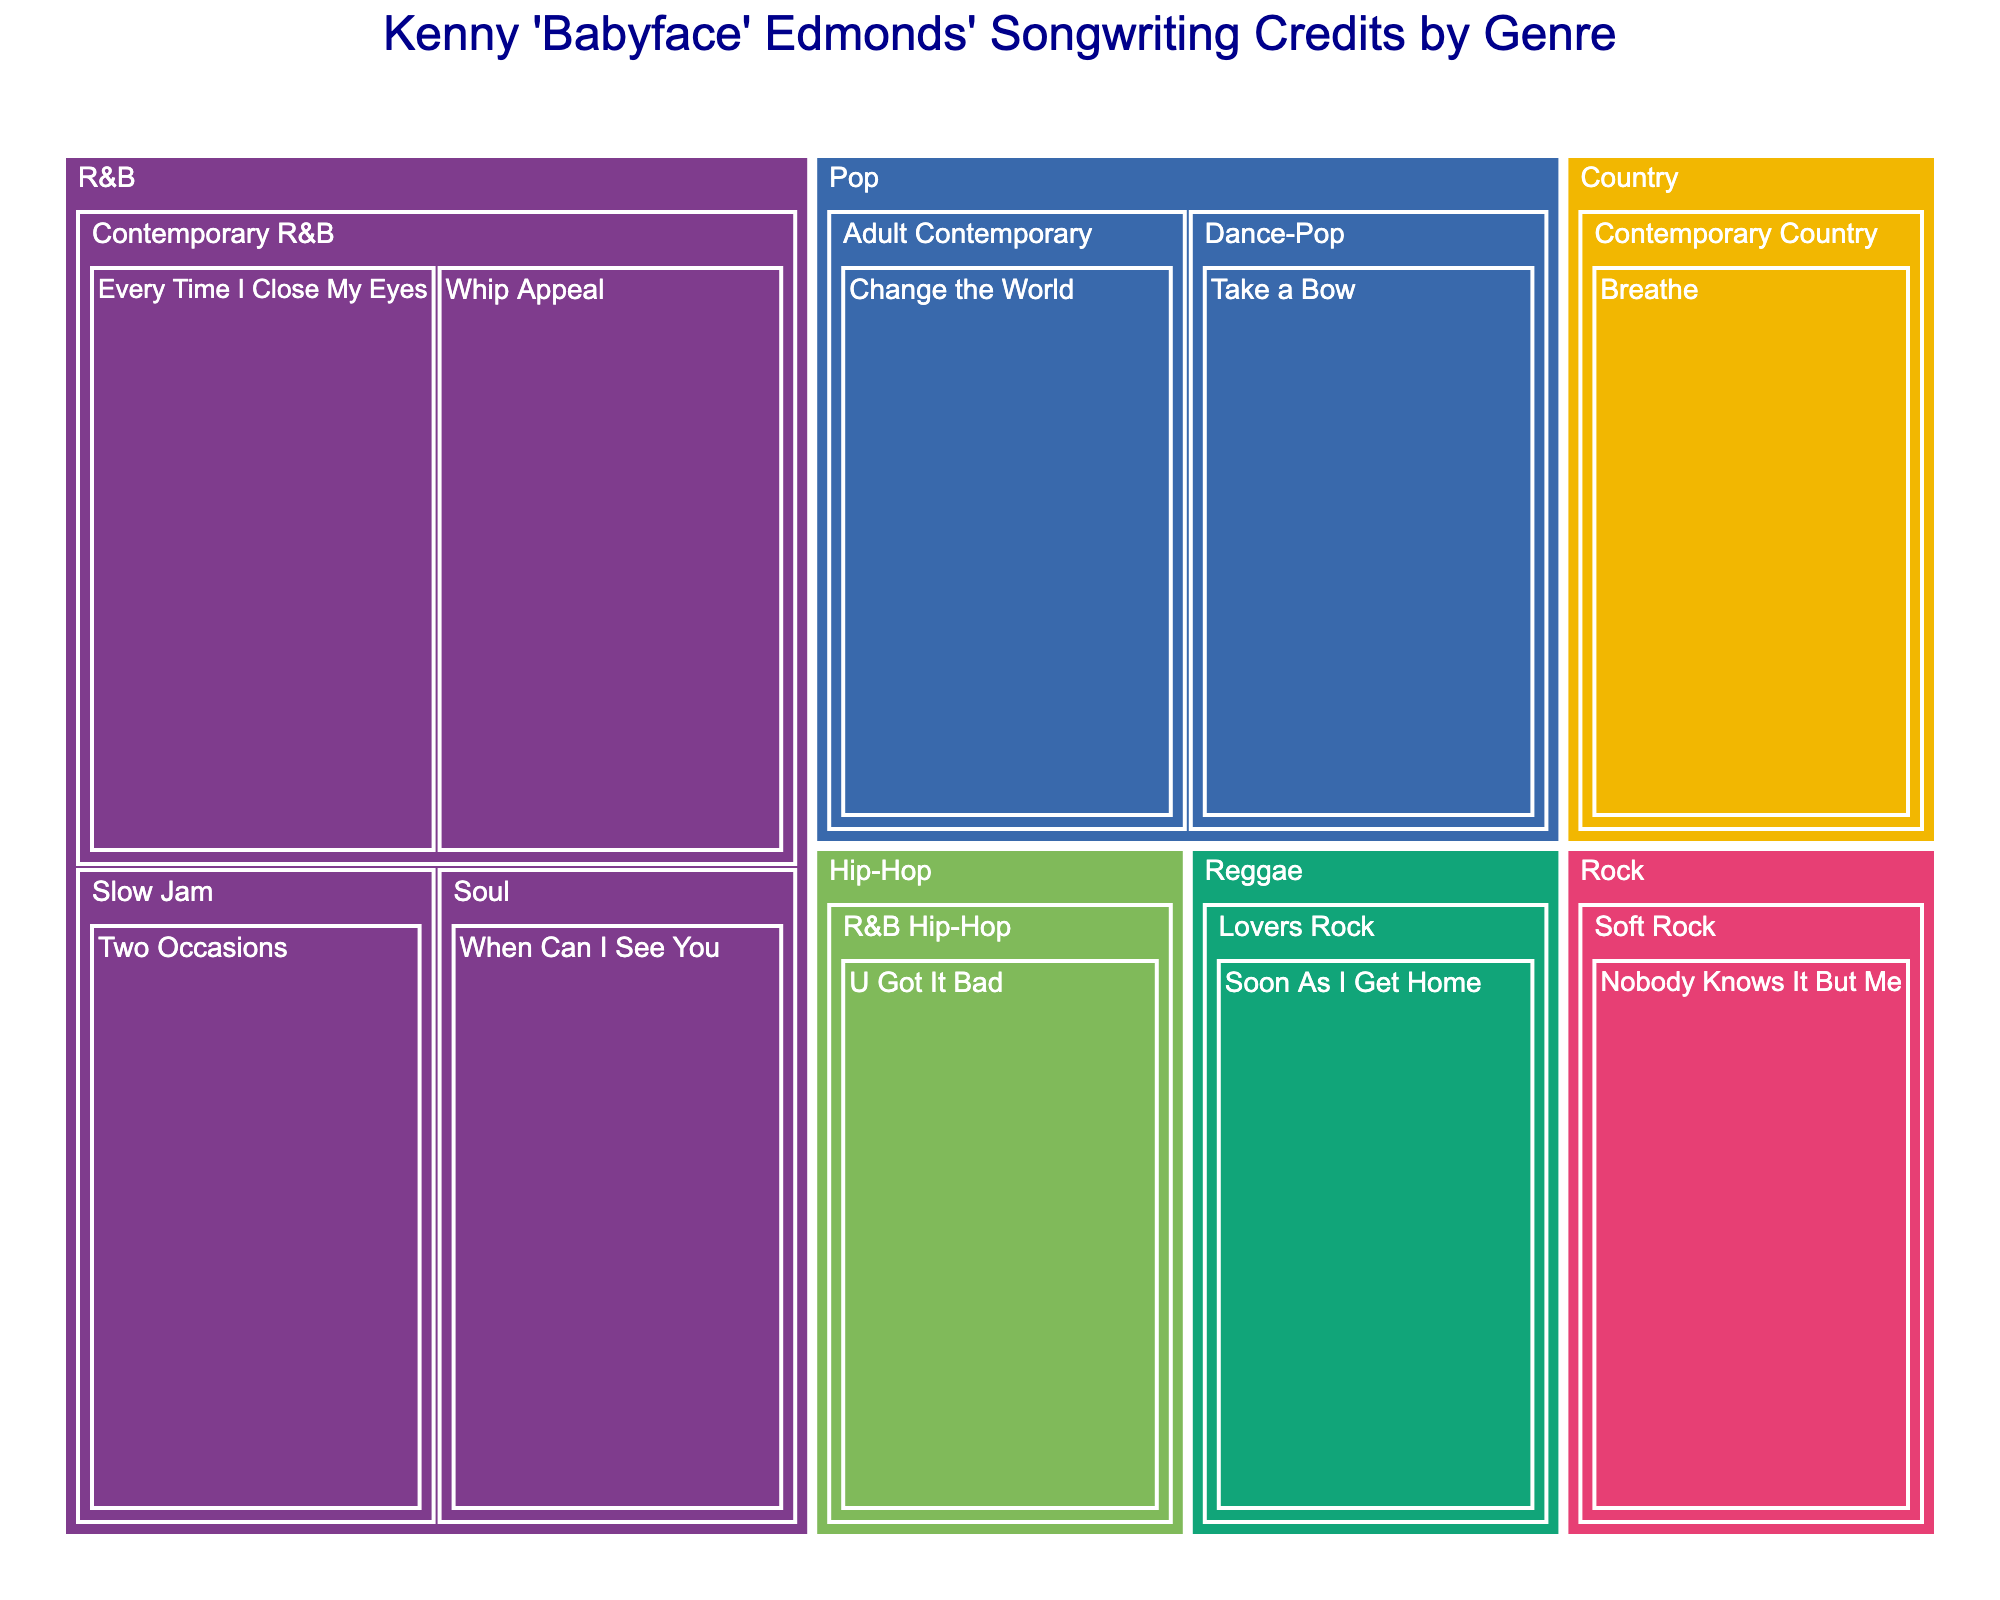How many genres are represented in the treemap? The treemap displays the songwriting credits broken down by genre. By counting the unique parent nodes (genres), you can see that there are 6 genres present: R&B, Pop, Hip-Hop, Rock, Country, and Reggae.
Answer: 6 Which genre has the most songwriting credits by Kenny 'Babyface' Edmonds? Each song title is a leaf node under its respective subgenre and genre. By counting the number of song titles (leaf nodes) under each genre, you can determine that R&B has the most songwriting credits.
Answer: R&B Are there any songs in the Hip-Hop genre? If so, what are they? In the treemap, the Hip-Hop genre will have a parent node, and its subgenres and songs will be leaf nodes. By identifying the leaf nodes under Hip-Hop, you can see that "U Got It Bad" is the only song listed.
Answer: Yes, "U Got It Bad" How many subgenres are there under the Pop genre? First, locate the Pop genre, then count the number of its children nodes, which are the subgenres. The leaf nodes under these will be the song titles. There are two subgenres under Pop: Adult Contemporary and Dance-Pop.
Answer: 2 Which genres have exactly one song associated with them? By examining the treemap and identifying which genres have only one leaf node (song title) under their hierarchy, you can find that Country, Rock, and Reggae each have only one song.
Answer: Country, Rock, Reggae Which subgenre in the R&B genre contains the song "Every Time I Close My Eyes"? Navigate the nodes under R&B in the treemap to find the subgenre containing the song "Every Time I Close My Eyes". It's located under Contemporary R&B.
Answer: Contemporary R&B Are there more songs in the Soul subgenre or the Slow Jam subgenre of R&B? First, identify the number of songs listed under the Soul and Slow Jam subgenres. The Soul subgenre has one song ("When Can I See You") while the Slow Jam subgenre also has one song ("Two Occasions").
Answer: Equal What's the title of the song listed under the Lovers Rock subgenre in the Reggae genre? Navigate through the treemap to find the Reggae genre and its subgenre Lovers Rock. The song title under this subgenre is "Soon As I Get Home".
Answer: "Soon As I Get Home" Which subgenre under the R&B genre has the most songs, and how many songs does it contain? By counting the number of leaf nodes (songs) under each subgenre of R&B (Contemporary R&B, Soul, Slow Jam), you determine that Contemporary R&B has the most with two songs.
Answer: Contemporary R&B, 2 songs 